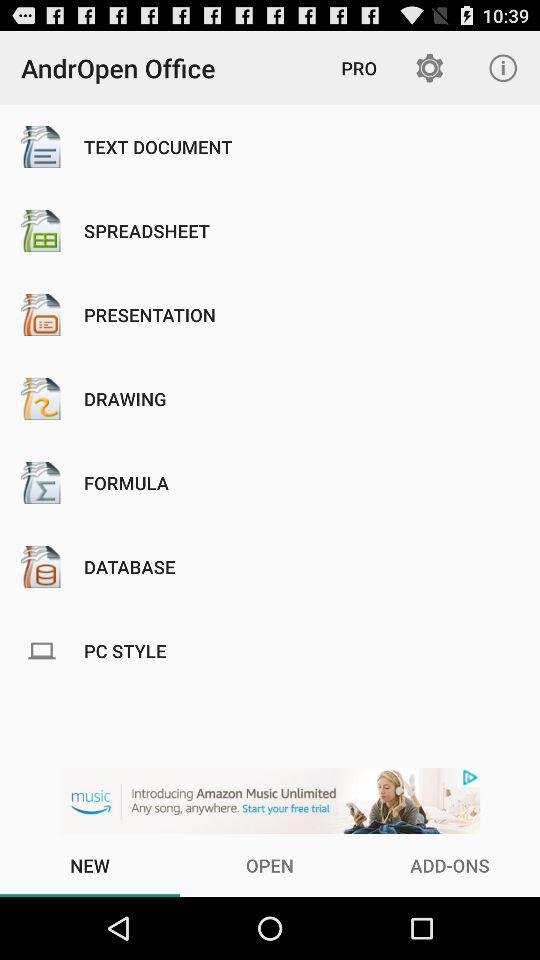What is the app name? The app name is "AndrOpen Office". 